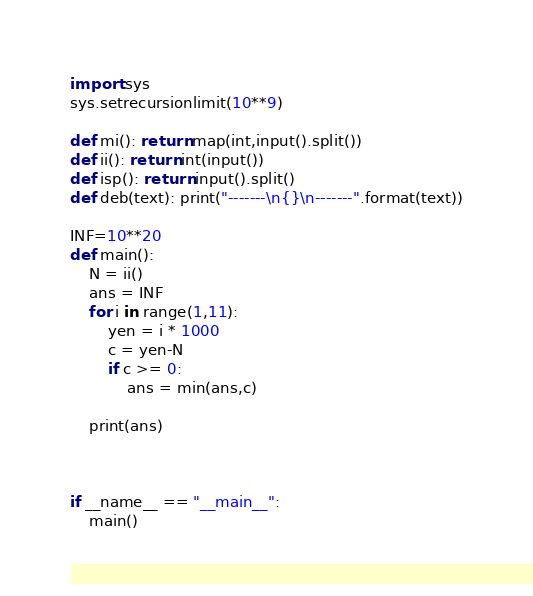Convert code to text. <code><loc_0><loc_0><loc_500><loc_500><_Python_>import sys
sys.setrecursionlimit(10**9)

def mi(): return map(int,input().split())
def ii(): return int(input())
def isp(): return input().split()
def deb(text): print("-------\n{}\n-------".format(text))

INF=10**20
def main():
    N = ii()
    ans = INF
    for i in range(1,11):
        yen = i * 1000
        c = yen-N
        if c >= 0:
            ans = min(ans,c)
        
    print(ans)



if __name__ == "__main__":
    main()</code> 